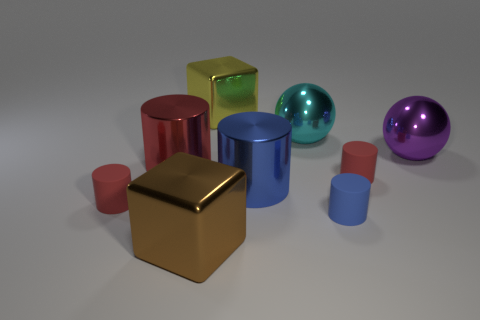Subtract all small red cylinders. How many cylinders are left? 3 Subtract all blue cylinders. How many cylinders are left? 3 Subtract all yellow spheres. How many red cylinders are left? 3 Add 2 blue matte cylinders. How many blue matte cylinders are left? 3 Add 3 cyan things. How many cyan things exist? 4 Subtract 0 gray spheres. How many objects are left? 9 Subtract all cylinders. How many objects are left? 4 Subtract all brown cylinders. Subtract all blue blocks. How many cylinders are left? 5 Subtract all cyan metallic balls. Subtract all big shiny cylinders. How many objects are left? 6 